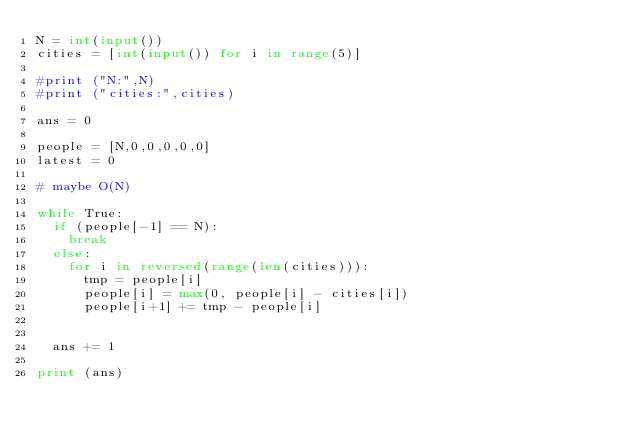<code> <loc_0><loc_0><loc_500><loc_500><_Python_>N = int(input())
cities = [int(input()) for i in range(5)]

#print ("N:",N)
#print ("cities:",cities)

ans = 0

people = [N,0,0,0,0,0]
latest = 0

# maybe O(N)

while True:
	if (people[-1] == N):
		break
	else:
		for i in reversed(range(len(cities))):
			tmp = people[i]
			people[i] = max(0, people[i] - cities[i])
			people[i+1] += tmp - people[i]


	ans += 1

print (ans)
</code> 